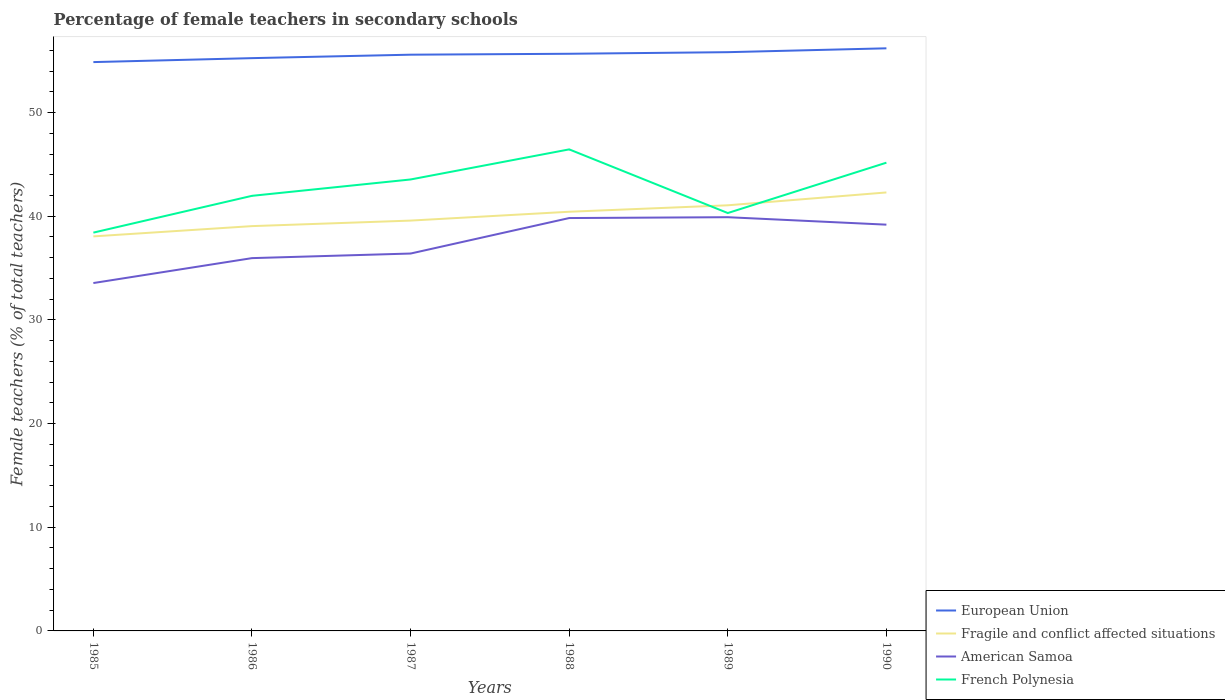How many different coloured lines are there?
Provide a succinct answer. 4. Does the line corresponding to French Polynesia intersect with the line corresponding to European Union?
Your response must be concise. No. Across all years, what is the maximum percentage of female teachers in American Samoa?
Offer a terse response. 33.56. In which year was the percentage of female teachers in French Polynesia maximum?
Make the answer very short. 1985. What is the total percentage of female teachers in American Samoa in the graph?
Your answer should be very brief. 0.64. What is the difference between the highest and the second highest percentage of female teachers in French Polynesia?
Your answer should be very brief. 8.03. What is the difference between the highest and the lowest percentage of female teachers in European Union?
Your response must be concise. 4. Is the percentage of female teachers in American Samoa strictly greater than the percentage of female teachers in Fragile and conflict affected situations over the years?
Your response must be concise. Yes. How many lines are there?
Offer a very short reply. 4. What is the difference between two consecutive major ticks on the Y-axis?
Make the answer very short. 10. Are the values on the major ticks of Y-axis written in scientific E-notation?
Make the answer very short. No. Does the graph contain any zero values?
Keep it short and to the point. No. Does the graph contain grids?
Offer a terse response. No. How are the legend labels stacked?
Keep it short and to the point. Vertical. What is the title of the graph?
Make the answer very short. Percentage of female teachers in secondary schools. What is the label or title of the X-axis?
Your answer should be compact. Years. What is the label or title of the Y-axis?
Your answer should be compact. Female teachers (% of total teachers). What is the Female teachers (% of total teachers) in European Union in 1985?
Your answer should be compact. 54.87. What is the Female teachers (% of total teachers) of Fragile and conflict affected situations in 1985?
Offer a very short reply. 38.06. What is the Female teachers (% of total teachers) of American Samoa in 1985?
Make the answer very short. 33.56. What is the Female teachers (% of total teachers) of French Polynesia in 1985?
Keep it short and to the point. 38.42. What is the Female teachers (% of total teachers) in European Union in 1986?
Provide a short and direct response. 55.25. What is the Female teachers (% of total teachers) of Fragile and conflict affected situations in 1986?
Your answer should be very brief. 39.05. What is the Female teachers (% of total teachers) in American Samoa in 1986?
Your response must be concise. 35.96. What is the Female teachers (% of total teachers) in French Polynesia in 1986?
Your answer should be very brief. 41.97. What is the Female teachers (% of total teachers) in European Union in 1987?
Provide a succinct answer. 55.58. What is the Female teachers (% of total teachers) in Fragile and conflict affected situations in 1987?
Keep it short and to the point. 39.58. What is the Female teachers (% of total teachers) of American Samoa in 1987?
Provide a succinct answer. 36.4. What is the Female teachers (% of total teachers) in French Polynesia in 1987?
Your answer should be very brief. 43.55. What is the Female teachers (% of total teachers) in European Union in 1988?
Your answer should be compact. 55.67. What is the Female teachers (% of total teachers) of Fragile and conflict affected situations in 1988?
Keep it short and to the point. 40.43. What is the Female teachers (% of total teachers) of American Samoa in 1988?
Your response must be concise. 39.83. What is the Female teachers (% of total teachers) in French Polynesia in 1988?
Keep it short and to the point. 46.45. What is the Female teachers (% of total teachers) of European Union in 1989?
Provide a short and direct response. 55.83. What is the Female teachers (% of total teachers) of Fragile and conflict affected situations in 1989?
Your answer should be very brief. 41.06. What is the Female teachers (% of total teachers) in American Samoa in 1989?
Ensure brevity in your answer.  39.91. What is the Female teachers (% of total teachers) in French Polynesia in 1989?
Keep it short and to the point. 40.31. What is the Female teachers (% of total teachers) in European Union in 1990?
Offer a terse response. 56.2. What is the Female teachers (% of total teachers) in Fragile and conflict affected situations in 1990?
Your answer should be very brief. 42.3. What is the Female teachers (% of total teachers) in American Samoa in 1990?
Provide a short and direct response. 39.19. What is the Female teachers (% of total teachers) of French Polynesia in 1990?
Offer a terse response. 45.17. Across all years, what is the maximum Female teachers (% of total teachers) of European Union?
Your answer should be compact. 56.2. Across all years, what is the maximum Female teachers (% of total teachers) of Fragile and conflict affected situations?
Ensure brevity in your answer.  42.3. Across all years, what is the maximum Female teachers (% of total teachers) of American Samoa?
Your answer should be compact. 39.91. Across all years, what is the maximum Female teachers (% of total teachers) of French Polynesia?
Offer a very short reply. 46.45. Across all years, what is the minimum Female teachers (% of total teachers) of European Union?
Offer a terse response. 54.87. Across all years, what is the minimum Female teachers (% of total teachers) in Fragile and conflict affected situations?
Provide a short and direct response. 38.06. Across all years, what is the minimum Female teachers (% of total teachers) of American Samoa?
Ensure brevity in your answer.  33.56. Across all years, what is the minimum Female teachers (% of total teachers) of French Polynesia?
Offer a terse response. 38.42. What is the total Female teachers (% of total teachers) in European Union in the graph?
Make the answer very short. 333.41. What is the total Female teachers (% of total teachers) in Fragile and conflict affected situations in the graph?
Ensure brevity in your answer.  240.48. What is the total Female teachers (% of total teachers) of American Samoa in the graph?
Provide a short and direct response. 224.85. What is the total Female teachers (% of total teachers) in French Polynesia in the graph?
Offer a very short reply. 255.87. What is the difference between the Female teachers (% of total teachers) of European Union in 1985 and that in 1986?
Ensure brevity in your answer.  -0.38. What is the difference between the Female teachers (% of total teachers) of Fragile and conflict affected situations in 1985 and that in 1986?
Give a very brief answer. -0.99. What is the difference between the Female teachers (% of total teachers) in American Samoa in 1985 and that in 1986?
Offer a terse response. -2.4. What is the difference between the Female teachers (% of total teachers) of French Polynesia in 1985 and that in 1986?
Keep it short and to the point. -3.55. What is the difference between the Female teachers (% of total teachers) of European Union in 1985 and that in 1987?
Your answer should be compact. -0.71. What is the difference between the Female teachers (% of total teachers) in Fragile and conflict affected situations in 1985 and that in 1987?
Give a very brief answer. -1.52. What is the difference between the Female teachers (% of total teachers) of American Samoa in 1985 and that in 1987?
Make the answer very short. -2.85. What is the difference between the Female teachers (% of total teachers) in French Polynesia in 1985 and that in 1987?
Make the answer very short. -5.13. What is the difference between the Female teachers (% of total teachers) of European Union in 1985 and that in 1988?
Make the answer very short. -0.8. What is the difference between the Female teachers (% of total teachers) in Fragile and conflict affected situations in 1985 and that in 1988?
Offer a very short reply. -2.38. What is the difference between the Female teachers (% of total teachers) in American Samoa in 1985 and that in 1988?
Provide a short and direct response. -6.27. What is the difference between the Female teachers (% of total teachers) in French Polynesia in 1985 and that in 1988?
Make the answer very short. -8.03. What is the difference between the Female teachers (% of total teachers) in European Union in 1985 and that in 1989?
Offer a terse response. -0.96. What is the difference between the Female teachers (% of total teachers) of Fragile and conflict affected situations in 1985 and that in 1989?
Offer a very short reply. -3. What is the difference between the Female teachers (% of total teachers) in American Samoa in 1985 and that in 1989?
Provide a short and direct response. -6.35. What is the difference between the Female teachers (% of total teachers) in French Polynesia in 1985 and that in 1989?
Make the answer very short. -1.89. What is the difference between the Female teachers (% of total teachers) of European Union in 1985 and that in 1990?
Give a very brief answer. -1.33. What is the difference between the Female teachers (% of total teachers) in Fragile and conflict affected situations in 1985 and that in 1990?
Provide a succinct answer. -4.24. What is the difference between the Female teachers (% of total teachers) in American Samoa in 1985 and that in 1990?
Offer a terse response. -5.63. What is the difference between the Female teachers (% of total teachers) of French Polynesia in 1985 and that in 1990?
Keep it short and to the point. -6.75. What is the difference between the Female teachers (% of total teachers) of European Union in 1986 and that in 1987?
Give a very brief answer. -0.33. What is the difference between the Female teachers (% of total teachers) in Fragile and conflict affected situations in 1986 and that in 1987?
Offer a terse response. -0.53. What is the difference between the Female teachers (% of total teachers) in American Samoa in 1986 and that in 1987?
Provide a succinct answer. -0.44. What is the difference between the Female teachers (% of total teachers) of French Polynesia in 1986 and that in 1987?
Give a very brief answer. -1.58. What is the difference between the Female teachers (% of total teachers) in European Union in 1986 and that in 1988?
Provide a short and direct response. -0.42. What is the difference between the Female teachers (% of total teachers) in Fragile and conflict affected situations in 1986 and that in 1988?
Ensure brevity in your answer.  -1.39. What is the difference between the Female teachers (% of total teachers) of American Samoa in 1986 and that in 1988?
Offer a very short reply. -3.87. What is the difference between the Female teachers (% of total teachers) of French Polynesia in 1986 and that in 1988?
Offer a terse response. -4.48. What is the difference between the Female teachers (% of total teachers) in European Union in 1986 and that in 1989?
Provide a short and direct response. -0.58. What is the difference between the Female teachers (% of total teachers) in Fragile and conflict affected situations in 1986 and that in 1989?
Your answer should be very brief. -2.01. What is the difference between the Female teachers (% of total teachers) of American Samoa in 1986 and that in 1989?
Your answer should be very brief. -3.95. What is the difference between the Female teachers (% of total teachers) of French Polynesia in 1986 and that in 1989?
Make the answer very short. 1.66. What is the difference between the Female teachers (% of total teachers) in European Union in 1986 and that in 1990?
Offer a terse response. -0.95. What is the difference between the Female teachers (% of total teachers) of Fragile and conflict affected situations in 1986 and that in 1990?
Offer a very short reply. -3.25. What is the difference between the Female teachers (% of total teachers) in American Samoa in 1986 and that in 1990?
Provide a succinct answer. -3.23. What is the difference between the Female teachers (% of total teachers) in French Polynesia in 1986 and that in 1990?
Give a very brief answer. -3.2. What is the difference between the Female teachers (% of total teachers) in European Union in 1987 and that in 1988?
Your answer should be compact. -0.09. What is the difference between the Female teachers (% of total teachers) of Fragile and conflict affected situations in 1987 and that in 1988?
Offer a very short reply. -0.85. What is the difference between the Female teachers (% of total teachers) of American Samoa in 1987 and that in 1988?
Offer a very short reply. -3.42. What is the difference between the Female teachers (% of total teachers) of French Polynesia in 1987 and that in 1988?
Your response must be concise. -2.9. What is the difference between the Female teachers (% of total teachers) in European Union in 1987 and that in 1989?
Your answer should be very brief. -0.24. What is the difference between the Female teachers (% of total teachers) of Fragile and conflict affected situations in 1987 and that in 1989?
Your answer should be very brief. -1.48. What is the difference between the Female teachers (% of total teachers) in American Samoa in 1987 and that in 1989?
Offer a very short reply. -3.5. What is the difference between the Female teachers (% of total teachers) in French Polynesia in 1987 and that in 1989?
Offer a very short reply. 3.24. What is the difference between the Female teachers (% of total teachers) of European Union in 1987 and that in 1990?
Offer a terse response. -0.62. What is the difference between the Female teachers (% of total teachers) of Fragile and conflict affected situations in 1987 and that in 1990?
Provide a short and direct response. -2.71. What is the difference between the Female teachers (% of total teachers) of American Samoa in 1987 and that in 1990?
Provide a short and direct response. -2.79. What is the difference between the Female teachers (% of total teachers) of French Polynesia in 1987 and that in 1990?
Keep it short and to the point. -1.62. What is the difference between the Female teachers (% of total teachers) in European Union in 1988 and that in 1989?
Your response must be concise. -0.15. What is the difference between the Female teachers (% of total teachers) in Fragile and conflict affected situations in 1988 and that in 1989?
Offer a terse response. -0.62. What is the difference between the Female teachers (% of total teachers) in American Samoa in 1988 and that in 1989?
Your answer should be very brief. -0.08. What is the difference between the Female teachers (% of total teachers) in French Polynesia in 1988 and that in 1989?
Provide a succinct answer. 6.14. What is the difference between the Female teachers (% of total teachers) of European Union in 1988 and that in 1990?
Provide a short and direct response. -0.53. What is the difference between the Female teachers (% of total teachers) of Fragile and conflict affected situations in 1988 and that in 1990?
Give a very brief answer. -1.86. What is the difference between the Female teachers (% of total teachers) in American Samoa in 1988 and that in 1990?
Provide a short and direct response. 0.64. What is the difference between the Female teachers (% of total teachers) of French Polynesia in 1988 and that in 1990?
Provide a succinct answer. 1.28. What is the difference between the Female teachers (% of total teachers) in European Union in 1989 and that in 1990?
Your answer should be very brief. -0.37. What is the difference between the Female teachers (% of total teachers) of Fragile and conflict affected situations in 1989 and that in 1990?
Offer a terse response. -1.24. What is the difference between the Female teachers (% of total teachers) of American Samoa in 1989 and that in 1990?
Your answer should be very brief. 0.72. What is the difference between the Female teachers (% of total teachers) of French Polynesia in 1989 and that in 1990?
Keep it short and to the point. -4.86. What is the difference between the Female teachers (% of total teachers) in European Union in 1985 and the Female teachers (% of total teachers) in Fragile and conflict affected situations in 1986?
Provide a short and direct response. 15.82. What is the difference between the Female teachers (% of total teachers) of European Union in 1985 and the Female teachers (% of total teachers) of American Samoa in 1986?
Provide a short and direct response. 18.91. What is the difference between the Female teachers (% of total teachers) in European Union in 1985 and the Female teachers (% of total teachers) in French Polynesia in 1986?
Offer a terse response. 12.9. What is the difference between the Female teachers (% of total teachers) of Fragile and conflict affected situations in 1985 and the Female teachers (% of total teachers) of American Samoa in 1986?
Give a very brief answer. 2.1. What is the difference between the Female teachers (% of total teachers) of Fragile and conflict affected situations in 1985 and the Female teachers (% of total teachers) of French Polynesia in 1986?
Offer a terse response. -3.91. What is the difference between the Female teachers (% of total teachers) of American Samoa in 1985 and the Female teachers (% of total teachers) of French Polynesia in 1986?
Offer a terse response. -8.41. What is the difference between the Female teachers (% of total teachers) in European Union in 1985 and the Female teachers (% of total teachers) in Fragile and conflict affected situations in 1987?
Offer a terse response. 15.29. What is the difference between the Female teachers (% of total teachers) in European Union in 1985 and the Female teachers (% of total teachers) in American Samoa in 1987?
Your answer should be very brief. 18.47. What is the difference between the Female teachers (% of total teachers) in European Union in 1985 and the Female teachers (% of total teachers) in French Polynesia in 1987?
Provide a short and direct response. 11.32. What is the difference between the Female teachers (% of total teachers) in Fragile and conflict affected situations in 1985 and the Female teachers (% of total teachers) in American Samoa in 1987?
Ensure brevity in your answer.  1.65. What is the difference between the Female teachers (% of total teachers) in Fragile and conflict affected situations in 1985 and the Female teachers (% of total teachers) in French Polynesia in 1987?
Ensure brevity in your answer.  -5.49. What is the difference between the Female teachers (% of total teachers) of American Samoa in 1985 and the Female teachers (% of total teachers) of French Polynesia in 1987?
Provide a succinct answer. -9.99. What is the difference between the Female teachers (% of total teachers) of European Union in 1985 and the Female teachers (% of total teachers) of Fragile and conflict affected situations in 1988?
Give a very brief answer. 14.44. What is the difference between the Female teachers (% of total teachers) in European Union in 1985 and the Female teachers (% of total teachers) in American Samoa in 1988?
Keep it short and to the point. 15.04. What is the difference between the Female teachers (% of total teachers) of European Union in 1985 and the Female teachers (% of total teachers) of French Polynesia in 1988?
Your answer should be compact. 8.42. What is the difference between the Female teachers (% of total teachers) of Fragile and conflict affected situations in 1985 and the Female teachers (% of total teachers) of American Samoa in 1988?
Offer a very short reply. -1.77. What is the difference between the Female teachers (% of total teachers) of Fragile and conflict affected situations in 1985 and the Female teachers (% of total teachers) of French Polynesia in 1988?
Offer a very short reply. -8.39. What is the difference between the Female teachers (% of total teachers) in American Samoa in 1985 and the Female teachers (% of total teachers) in French Polynesia in 1988?
Offer a very short reply. -12.89. What is the difference between the Female teachers (% of total teachers) in European Union in 1985 and the Female teachers (% of total teachers) in Fragile and conflict affected situations in 1989?
Offer a terse response. 13.81. What is the difference between the Female teachers (% of total teachers) in European Union in 1985 and the Female teachers (% of total teachers) in American Samoa in 1989?
Your answer should be very brief. 14.96. What is the difference between the Female teachers (% of total teachers) in European Union in 1985 and the Female teachers (% of total teachers) in French Polynesia in 1989?
Offer a terse response. 14.56. What is the difference between the Female teachers (% of total teachers) in Fragile and conflict affected situations in 1985 and the Female teachers (% of total teachers) in American Samoa in 1989?
Offer a very short reply. -1.85. What is the difference between the Female teachers (% of total teachers) of Fragile and conflict affected situations in 1985 and the Female teachers (% of total teachers) of French Polynesia in 1989?
Give a very brief answer. -2.25. What is the difference between the Female teachers (% of total teachers) of American Samoa in 1985 and the Female teachers (% of total teachers) of French Polynesia in 1989?
Provide a succinct answer. -6.75. What is the difference between the Female teachers (% of total teachers) of European Union in 1985 and the Female teachers (% of total teachers) of Fragile and conflict affected situations in 1990?
Provide a succinct answer. 12.57. What is the difference between the Female teachers (% of total teachers) of European Union in 1985 and the Female teachers (% of total teachers) of American Samoa in 1990?
Ensure brevity in your answer.  15.68. What is the difference between the Female teachers (% of total teachers) in European Union in 1985 and the Female teachers (% of total teachers) in French Polynesia in 1990?
Offer a terse response. 9.7. What is the difference between the Female teachers (% of total teachers) in Fragile and conflict affected situations in 1985 and the Female teachers (% of total teachers) in American Samoa in 1990?
Your answer should be compact. -1.13. What is the difference between the Female teachers (% of total teachers) of Fragile and conflict affected situations in 1985 and the Female teachers (% of total teachers) of French Polynesia in 1990?
Provide a short and direct response. -7.11. What is the difference between the Female teachers (% of total teachers) in American Samoa in 1985 and the Female teachers (% of total teachers) in French Polynesia in 1990?
Ensure brevity in your answer.  -11.61. What is the difference between the Female teachers (% of total teachers) of European Union in 1986 and the Female teachers (% of total teachers) of Fragile and conflict affected situations in 1987?
Keep it short and to the point. 15.67. What is the difference between the Female teachers (% of total teachers) in European Union in 1986 and the Female teachers (% of total teachers) in American Samoa in 1987?
Your answer should be very brief. 18.85. What is the difference between the Female teachers (% of total teachers) of European Union in 1986 and the Female teachers (% of total teachers) of French Polynesia in 1987?
Make the answer very short. 11.7. What is the difference between the Female teachers (% of total teachers) in Fragile and conflict affected situations in 1986 and the Female teachers (% of total teachers) in American Samoa in 1987?
Provide a short and direct response. 2.65. What is the difference between the Female teachers (% of total teachers) in Fragile and conflict affected situations in 1986 and the Female teachers (% of total teachers) in French Polynesia in 1987?
Provide a short and direct response. -4.5. What is the difference between the Female teachers (% of total teachers) of American Samoa in 1986 and the Female teachers (% of total teachers) of French Polynesia in 1987?
Give a very brief answer. -7.59. What is the difference between the Female teachers (% of total teachers) of European Union in 1986 and the Female teachers (% of total teachers) of Fragile and conflict affected situations in 1988?
Your answer should be compact. 14.82. What is the difference between the Female teachers (% of total teachers) in European Union in 1986 and the Female teachers (% of total teachers) in American Samoa in 1988?
Your answer should be very brief. 15.43. What is the difference between the Female teachers (% of total teachers) of European Union in 1986 and the Female teachers (% of total teachers) of French Polynesia in 1988?
Keep it short and to the point. 8.8. What is the difference between the Female teachers (% of total teachers) of Fragile and conflict affected situations in 1986 and the Female teachers (% of total teachers) of American Samoa in 1988?
Keep it short and to the point. -0.78. What is the difference between the Female teachers (% of total teachers) of Fragile and conflict affected situations in 1986 and the Female teachers (% of total teachers) of French Polynesia in 1988?
Provide a succinct answer. -7.4. What is the difference between the Female teachers (% of total teachers) in American Samoa in 1986 and the Female teachers (% of total teachers) in French Polynesia in 1988?
Give a very brief answer. -10.49. What is the difference between the Female teachers (% of total teachers) in European Union in 1986 and the Female teachers (% of total teachers) in Fragile and conflict affected situations in 1989?
Keep it short and to the point. 14.2. What is the difference between the Female teachers (% of total teachers) in European Union in 1986 and the Female teachers (% of total teachers) in American Samoa in 1989?
Offer a very short reply. 15.34. What is the difference between the Female teachers (% of total teachers) of European Union in 1986 and the Female teachers (% of total teachers) of French Polynesia in 1989?
Your response must be concise. 14.94. What is the difference between the Female teachers (% of total teachers) of Fragile and conflict affected situations in 1986 and the Female teachers (% of total teachers) of American Samoa in 1989?
Make the answer very short. -0.86. What is the difference between the Female teachers (% of total teachers) in Fragile and conflict affected situations in 1986 and the Female teachers (% of total teachers) in French Polynesia in 1989?
Provide a succinct answer. -1.26. What is the difference between the Female teachers (% of total teachers) in American Samoa in 1986 and the Female teachers (% of total teachers) in French Polynesia in 1989?
Provide a short and direct response. -4.35. What is the difference between the Female teachers (% of total teachers) of European Union in 1986 and the Female teachers (% of total teachers) of Fragile and conflict affected situations in 1990?
Make the answer very short. 12.96. What is the difference between the Female teachers (% of total teachers) in European Union in 1986 and the Female teachers (% of total teachers) in American Samoa in 1990?
Ensure brevity in your answer.  16.06. What is the difference between the Female teachers (% of total teachers) of European Union in 1986 and the Female teachers (% of total teachers) of French Polynesia in 1990?
Offer a terse response. 10.08. What is the difference between the Female teachers (% of total teachers) in Fragile and conflict affected situations in 1986 and the Female teachers (% of total teachers) in American Samoa in 1990?
Give a very brief answer. -0.14. What is the difference between the Female teachers (% of total teachers) in Fragile and conflict affected situations in 1986 and the Female teachers (% of total teachers) in French Polynesia in 1990?
Offer a very short reply. -6.12. What is the difference between the Female teachers (% of total teachers) in American Samoa in 1986 and the Female teachers (% of total teachers) in French Polynesia in 1990?
Your answer should be very brief. -9.21. What is the difference between the Female teachers (% of total teachers) in European Union in 1987 and the Female teachers (% of total teachers) in Fragile and conflict affected situations in 1988?
Your answer should be very brief. 15.15. What is the difference between the Female teachers (% of total teachers) of European Union in 1987 and the Female teachers (% of total teachers) of American Samoa in 1988?
Make the answer very short. 15.76. What is the difference between the Female teachers (% of total teachers) of European Union in 1987 and the Female teachers (% of total teachers) of French Polynesia in 1988?
Keep it short and to the point. 9.13. What is the difference between the Female teachers (% of total teachers) in Fragile and conflict affected situations in 1987 and the Female teachers (% of total teachers) in American Samoa in 1988?
Ensure brevity in your answer.  -0.24. What is the difference between the Female teachers (% of total teachers) of Fragile and conflict affected situations in 1987 and the Female teachers (% of total teachers) of French Polynesia in 1988?
Your answer should be very brief. -6.87. What is the difference between the Female teachers (% of total teachers) in American Samoa in 1987 and the Female teachers (% of total teachers) in French Polynesia in 1988?
Offer a terse response. -10.05. What is the difference between the Female teachers (% of total teachers) of European Union in 1987 and the Female teachers (% of total teachers) of Fragile and conflict affected situations in 1989?
Offer a terse response. 14.53. What is the difference between the Female teachers (% of total teachers) of European Union in 1987 and the Female teachers (% of total teachers) of American Samoa in 1989?
Ensure brevity in your answer.  15.68. What is the difference between the Female teachers (% of total teachers) of European Union in 1987 and the Female teachers (% of total teachers) of French Polynesia in 1989?
Give a very brief answer. 15.27. What is the difference between the Female teachers (% of total teachers) in Fragile and conflict affected situations in 1987 and the Female teachers (% of total teachers) in American Samoa in 1989?
Ensure brevity in your answer.  -0.33. What is the difference between the Female teachers (% of total teachers) of Fragile and conflict affected situations in 1987 and the Female teachers (% of total teachers) of French Polynesia in 1989?
Give a very brief answer. -0.73. What is the difference between the Female teachers (% of total teachers) in American Samoa in 1987 and the Female teachers (% of total teachers) in French Polynesia in 1989?
Give a very brief answer. -3.91. What is the difference between the Female teachers (% of total teachers) in European Union in 1987 and the Female teachers (% of total teachers) in Fragile and conflict affected situations in 1990?
Your response must be concise. 13.29. What is the difference between the Female teachers (% of total teachers) of European Union in 1987 and the Female teachers (% of total teachers) of American Samoa in 1990?
Offer a very short reply. 16.4. What is the difference between the Female teachers (% of total teachers) in European Union in 1987 and the Female teachers (% of total teachers) in French Polynesia in 1990?
Provide a succinct answer. 10.42. What is the difference between the Female teachers (% of total teachers) of Fragile and conflict affected situations in 1987 and the Female teachers (% of total teachers) of American Samoa in 1990?
Ensure brevity in your answer.  0.39. What is the difference between the Female teachers (% of total teachers) of Fragile and conflict affected situations in 1987 and the Female teachers (% of total teachers) of French Polynesia in 1990?
Provide a succinct answer. -5.59. What is the difference between the Female teachers (% of total teachers) in American Samoa in 1987 and the Female teachers (% of total teachers) in French Polynesia in 1990?
Offer a terse response. -8.77. What is the difference between the Female teachers (% of total teachers) of European Union in 1988 and the Female teachers (% of total teachers) of Fragile and conflict affected situations in 1989?
Offer a terse response. 14.62. What is the difference between the Female teachers (% of total teachers) in European Union in 1988 and the Female teachers (% of total teachers) in American Samoa in 1989?
Offer a very short reply. 15.77. What is the difference between the Female teachers (% of total teachers) of European Union in 1988 and the Female teachers (% of total teachers) of French Polynesia in 1989?
Provide a short and direct response. 15.36. What is the difference between the Female teachers (% of total teachers) of Fragile and conflict affected situations in 1988 and the Female teachers (% of total teachers) of American Samoa in 1989?
Your answer should be very brief. 0.53. What is the difference between the Female teachers (% of total teachers) in Fragile and conflict affected situations in 1988 and the Female teachers (% of total teachers) in French Polynesia in 1989?
Provide a succinct answer. 0.12. What is the difference between the Female teachers (% of total teachers) in American Samoa in 1988 and the Female teachers (% of total teachers) in French Polynesia in 1989?
Give a very brief answer. -0.48. What is the difference between the Female teachers (% of total teachers) in European Union in 1988 and the Female teachers (% of total teachers) in Fragile and conflict affected situations in 1990?
Make the answer very short. 13.38. What is the difference between the Female teachers (% of total teachers) of European Union in 1988 and the Female teachers (% of total teachers) of American Samoa in 1990?
Offer a very short reply. 16.48. What is the difference between the Female teachers (% of total teachers) of European Union in 1988 and the Female teachers (% of total teachers) of French Polynesia in 1990?
Your answer should be very brief. 10.51. What is the difference between the Female teachers (% of total teachers) of Fragile and conflict affected situations in 1988 and the Female teachers (% of total teachers) of American Samoa in 1990?
Provide a succinct answer. 1.25. What is the difference between the Female teachers (% of total teachers) in Fragile and conflict affected situations in 1988 and the Female teachers (% of total teachers) in French Polynesia in 1990?
Make the answer very short. -4.73. What is the difference between the Female teachers (% of total teachers) of American Samoa in 1988 and the Female teachers (% of total teachers) of French Polynesia in 1990?
Your answer should be very brief. -5.34. What is the difference between the Female teachers (% of total teachers) of European Union in 1989 and the Female teachers (% of total teachers) of Fragile and conflict affected situations in 1990?
Ensure brevity in your answer.  13.53. What is the difference between the Female teachers (% of total teachers) of European Union in 1989 and the Female teachers (% of total teachers) of American Samoa in 1990?
Ensure brevity in your answer.  16.64. What is the difference between the Female teachers (% of total teachers) in European Union in 1989 and the Female teachers (% of total teachers) in French Polynesia in 1990?
Offer a terse response. 10.66. What is the difference between the Female teachers (% of total teachers) in Fragile and conflict affected situations in 1989 and the Female teachers (% of total teachers) in American Samoa in 1990?
Offer a very short reply. 1.87. What is the difference between the Female teachers (% of total teachers) in Fragile and conflict affected situations in 1989 and the Female teachers (% of total teachers) in French Polynesia in 1990?
Your answer should be very brief. -4.11. What is the difference between the Female teachers (% of total teachers) of American Samoa in 1989 and the Female teachers (% of total teachers) of French Polynesia in 1990?
Your answer should be compact. -5.26. What is the average Female teachers (% of total teachers) of European Union per year?
Give a very brief answer. 55.57. What is the average Female teachers (% of total teachers) of Fragile and conflict affected situations per year?
Your answer should be very brief. 40.08. What is the average Female teachers (% of total teachers) of American Samoa per year?
Your answer should be compact. 37.47. What is the average Female teachers (% of total teachers) of French Polynesia per year?
Offer a very short reply. 42.65. In the year 1985, what is the difference between the Female teachers (% of total teachers) of European Union and Female teachers (% of total teachers) of Fragile and conflict affected situations?
Offer a terse response. 16.81. In the year 1985, what is the difference between the Female teachers (% of total teachers) of European Union and Female teachers (% of total teachers) of American Samoa?
Offer a very short reply. 21.31. In the year 1985, what is the difference between the Female teachers (% of total teachers) in European Union and Female teachers (% of total teachers) in French Polynesia?
Your answer should be very brief. 16.45. In the year 1985, what is the difference between the Female teachers (% of total teachers) of Fragile and conflict affected situations and Female teachers (% of total teachers) of American Samoa?
Provide a succinct answer. 4.5. In the year 1985, what is the difference between the Female teachers (% of total teachers) of Fragile and conflict affected situations and Female teachers (% of total teachers) of French Polynesia?
Your response must be concise. -0.36. In the year 1985, what is the difference between the Female teachers (% of total teachers) in American Samoa and Female teachers (% of total teachers) in French Polynesia?
Ensure brevity in your answer.  -4.86. In the year 1986, what is the difference between the Female teachers (% of total teachers) of European Union and Female teachers (% of total teachers) of Fragile and conflict affected situations?
Offer a terse response. 16.2. In the year 1986, what is the difference between the Female teachers (% of total teachers) in European Union and Female teachers (% of total teachers) in American Samoa?
Offer a very short reply. 19.29. In the year 1986, what is the difference between the Female teachers (% of total teachers) in European Union and Female teachers (% of total teachers) in French Polynesia?
Your answer should be very brief. 13.28. In the year 1986, what is the difference between the Female teachers (% of total teachers) in Fragile and conflict affected situations and Female teachers (% of total teachers) in American Samoa?
Your answer should be very brief. 3.09. In the year 1986, what is the difference between the Female teachers (% of total teachers) of Fragile and conflict affected situations and Female teachers (% of total teachers) of French Polynesia?
Provide a short and direct response. -2.92. In the year 1986, what is the difference between the Female teachers (% of total teachers) in American Samoa and Female teachers (% of total teachers) in French Polynesia?
Your response must be concise. -6.01. In the year 1987, what is the difference between the Female teachers (% of total teachers) in European Union and Female teachers (% of total teachers) in Fragile and conflict affected situations?
Your response must be concise. 16. In the year 1987, what is the difference between the Female teachers (% of total teachers) of European Union and Female teachers (% of total teachers) of American Samoa?
Your answer should be compact. 19.18. In the year 1987, what is the difference between the Female teachers (% of total teachers) of European Union and Female teachers (% of total teachers) of French Polynesia?
Offer a very short reply. 12.04. In the year 1987, what is the difference between the Female teachers (% of total teachers) of Fragile and conflict affected situations and Female teachers (% of total teachers) of American Samoa?
Provide a short and direct response. 3.18. In the year 1987, what is the difference between the Female teachers (% of total teachers) in Fragile and conflict affected situations and Female teachers (% of total teachers) in French Polynesia?
Keep it short and to the point. -3.97. In the year 1987, what is the difference between the Female teachers (% of total teachers) in American Samoa and Female teachers (% of total teachers) in French Polynesia?
Keep it short and to the point. -7.14. In the year 1988, what is the difference between the Female teachers (% of total teachers) of European Union and Female teachers (% of total teachers) of Fragile and conflict affected situations?
Your answer should be compact. 15.24. In the year 1988, what is the difference between the Female teachers (% of total teachers) of European Union and Female teachers (% of total teachers) of American Samoa?
Offer a very short reply. 15.85. In the year 1988, what is the difference between the Female teachers (% of total teachers) in European Union and Female teachers (% of total teachers) in French Polynesia?
Your response must be concise. 9.22. In the year 1988, what is the difference between the Female teachers (% of total teachers) in Fragile and conflict affected situations and Female teachers (% of total teachers) in American Samoa?
Provide a succinct answer. 0.61. In the year 1988, what is the difference between the Female teachers (% of total teachers) of Fragile and conflict affected situations and Female teachers (% of total teachers) of French Polynesia?
Keep it short and to the point. -6.02. In the year 1988, what is the difference between the Female teachers (% of total teachers) in American Samoa and Female teachers (% of total teachers) in French Polynesia?
Keep it short and to the point. -6.62. In the year 1989, what is the difference between the Female teachers (% of total teachers) of European Union and Female teachers (% of total teachers) of Fragile and conflict affected situations?
Provide a short and direct response. 14.77. In the year 1989, what is the difference between the Female teachers (% of total teachers) in European Union and Female teachers (% of total teachers) in American Samoa?
Keep it short and to the point. 15.92. In the year 1989, what is the difference between the Female teachers (% of total teachers) in European Union and Female teachers (% of total teachers) in French Polynesia?
Provide a short and direct response. 15.52. In the year 1989, what is the difference between the Female teachers (% of total teachers) of Fragile and conflict affected situations and Female teachers (% of total teachers) of American Samoa?
Your response must be concise. 1.15. In the year 1989, what is the difference between the Female teachers (% of total teachers) in Fragile and conflict affected situations and Female teachers (% of total teachers) in French Polynesia?
Provide a succinct answer. 0.75. In the year 1989, what is the difference between the Female teachers (% of total teachers) in American Samoa and Female teachers (% of total teachers) in French Polynesia?
Offer a very short reply. -0.4. In the year 1990, what is the difference between the Female teachers (% of total teachers) in European Union and Female teachers (% of total teachers) in Fragile and conflict affected situations?
Provide a short and direct response. 13.9. In the year 1990, what is the difference between the Female teachers (% of total teachers) of European Union and Female teachers (% of total teachers) of American Samoa?
Your answer should be very brief. 17.01. In the year 1990, what is the difference between the Female teachers (% of total teachers) in European Union and Female teachers (% of total teachers) in French Polynesia?
Make the answer very short. 11.03. In the year 1990, what is the difference between the Female teachers (% of total teachers) in Fragile and conflict affected situations and Female teachers (% of total teachers) in American Samoa?
Your answer should be very brief. 3.11. In the year 1990, what is the difference between the Female teachers (% of total teachers) in Fragile and conflict affected situations and Female teachers (% of total teachers) in French Polynesia?
Offer a terse response. -2.87. In the year 1990, what is the difference between the Female teachers (% of total teachers) in American Samoa and Female teachers (% of total teachers) in French Polynesia?
Give a very brief answer. -5.98. What is the ratio of the Female teachers (% of total teachers) of European Union in 1985 to that in 1986?
Make the answer very short. 0.99. What is the ratio of the Female teachers (% of total teachers) of Fragile and conflict affected situations in 1985 to that in 1986?
Provide a short and direct response. 0.97. What is the ratio of the Female teachers (% of total teachers) of American Samoa in 1985 to that in 1986?
Your response must be concise. 0.93. What is the ratio of the Female teachers (% of total teachers) of French Polynesia in 1985 to that in 1986?
Your answer should be compact. 0.92. What is the ratio of the Female teachers (% of total teachers) of European Union in 1985 to that in 1987?
Offer a very short reply. 0.99. What is the ratio of the Female teachers (% of total teachers) of Fragile and conflict affected situations in 1985 to that in 1987?
Give a very brief answer. 0.96. What is the ratio of the Female teachers (% of total teachers) in American Samoa in 1985 to that in 1987?
Offer a terse response. 0.92. What is the ratio of the Female teachers (% of total teachers) in French Polynesia in 1985 to that in 1987?
Your response must be concise. 0.88. What is the ratio of the Female teachers (% of total teachers) of European Union in 1985 to that in 1988?
Offer a very short reply. 0.99. What is the ratio of the Female teachers (% of total teachers) of Fragile and conflict affected situations in 1985 to that in 1988?
Offer a terse response. 0.94. What is the ratio of the Female teachers (% of total teachers) of American Samoa in 1985 to that in 1988?
Offer a terse response. 0.84. What is the ratio of the Female teachers (% of total teachers) in French Polynesia in 1985 to that in 1988?
Give a very brief answer. 0.83. What is the ratio of the Female teachers (% of total teachers) in European Union in 1985 to that in 1989?
Keep it short and to the point. 0.98. What is the ratio of the Female teachers (% of total teachers) in Fragile and conflict affected situations in 1985 to that in 1989?
Provide a succinct answer. 0.93. What is the ratio of the Female teachers (% of total teachers) in American Samoa in 1985 to that in 1989?
Keep it short and to the point. 0.84. What is the ratio of the Female teachers (% of total teachers) in French Polynesia in 1985 to that in 1989?
Offer a very short reply. 0.95. What is the ratio of the Female teachers (% of total teachers) in European Union in 1985 to that in 1990?
Ensure brevity in your answer.  0.98. What is the ratio of the Female teachers (% of total teachers) in Fragile and conflict affected situations in 1985 to that in 1990?
Provide a succinct answer. 0.9. What is the ratio of the Female teachers (% of total teachers) in American Samoa in 1985 to that in 1990?
Make the answer very short. 0.86. What is the ratio of the Female teachers (% of total teachers) of French Polynesia in 1985 to that in 1990?
Ensure brevity in your answer.  0.85. What is the ratio of the Female teachers (% of total teachers) in European Union in 1986 to that in 1987?
Make the answer very short. 0.99. What is the ratio of the Female teachers (% of total teachers) in Fragile and conflict affected situations in 1986 to that in 1987?
Keep it short and to the point. 0.99. What is the ratio of the Female teachers (% of total teachers) in American Samoa in 1986 to that in 1987?
Give a very brief answer. 0.99. What is the ratio of the Female teachers (% of total teachers) in French Polynesia in 1986 to that in 1987?
Your response must be concise. 0.96. What is the ratio of the Female teachers (% of total teachers) of European Union in 1986 to that in 1988?
Keep it short and to the point. 0.99. What is the ratio of the Female teachers (% of total teachers) in Fragile and conflict affected situations in 1986 to that in 1988?
Offer a very short reply. 0.97. What is the ratio of the Female teachers (% of total teachers) of American Samoa in 1986 to that in 1988?
Offer a terse response. 0.9. What is the ratio of the Female teachers (% of total teachers) of French Polynesia in 1986 to that in 1988?
Your answer should be very brief. 0.9. What is the ratio of the Female teachers (% of total teachers) in European Union in 1986 to that in 1989?
Provide a short and direct response. 0.99. What is the ratio of the Female teachers (% of total teachers) in Fragile and conflict affected situations in 1986 to that in 1989?
Keep it short and to the point. 0.95. What is the ratio of the Female teachers (% of total teachers) in American Samoa in 1986 to that in 1989?
Your answer should be compact. 0.9. What is the ratio of the Female teachers (% of total teachers) of French Polynesia in 1986 to that in 1989?
Your response must be concise. 1.04. What is the ratio of the Female teachers (% of total teachers) of European Union in 1986 to that in 1990?
Your response must be concise. 0.98. What is the ratio of the Female teachers (% of total teachers) in Fragile and conflict affected situations in 1986 to that in 1990?
Keep it short and to the point. 0.92. What is the ratio of the Female teachers (% of total teachers) of American Samoa in 1986 to that in 1990?
Give a very brief answer. 0.92. What is the ratio of the Female teachers (% of total teachers) of French Polynesia in 1986 to that in 1990?
Offer a very short reply. 0.93. What is the ratio of the Female teachers (% of total teachers) of Fragile and conflict affected situations in 1987 to that in 1988?
Provide a succinct answer. 0.98. What is the ratio of the Female teachers (% of total teachers) of American Samoa in 1987 to that in 1988?
Keep it short and to the point. 0.91. What is the ratio of the Female teachers (% of total teachers) in French Polynesia in 1987 to that in 1988?
Provide a short and direct response. 0.94. What is the ratio of the Female teachers (% of total teachers) in European Union in 1987 to that in 1989?
Your answer should be compact. 1. What is the ratio of the Female teachers (% of total teachers) of Fragile and conflict affected situations in 1987 to that in 1989?
Keep it short and to the point. 0.96. What is the ratio of the Female teachers (% of total teachers) in American Samoa in 1987 to that in 1989?
Your answer should be very brief. 0.91. What is the ratio of the Female teachers (% of total teachers) in French Polynesia in 1987 to that in 1989?
Offer a terse response. 1.08. What is the ratio of the Female teachers (% of total teachers) in European Union in 1987 to that in 1990?
Your answer should be compact. 0.99. What is the ratio of the Female teachers (% of total teachers) in Fragile and conflict affected situations in 1987 to that in 1990?
Offer a very short reply. 0.94. What is the ratio of the Female teachers (% of total teachers) of American Samoa in 1987 to that in 1990?
Provide a short and direct response. 0.93. What is the ratio of the Female teachers (% of total teachers) in French Polynesia in 1987 to that in 1990?
Provide a short and direct response. 0.96. What is the ratio of the Female teachers (% of total teachers) of European Union in 1988 to that in 1989?
Provide a short and direct response. 1. What is the ratio of the Female teachers (% of total teachers) of American Samoa in 1988 to that in 1989?
Offer a very short reply. 1. What is the ratio of the Female teachers (% of total teachers) of French Polynesia in 1988 to that in 1989?
Ensure brevity in your answer.  1.15. What is the ratio of the Female teachers (% of total teachers) in European Union in 1988 to that in 1990?
Your answer should be compact. 0.99. What is the ratio of the Female teachers (% of total teachers) in Fragile and conflict affected situations in 1988 to that in 1990?
Provide a succinct answer. 0.96. What is the ratio of the Female teachers (% of total teachers) of American Samoa in 1988 to that in 1990?
Keep it short and to the point. 1.02. What is the ratio of the Female teachers (% of total teachers) in French Polynesia in 1988 to that in 1990?
Provide a succinct answer. 1.03. What is the ratio of the Female teachers (% of total teachers) of European Union in 1989 to that in 1990?
Your answer should be very brief. 0.99. What is the ratio of the Female teachers (% of total teachers) of Fragile and conflict affected situations in 1989 to that in 1990?
Ensure brevity in your answer.  0.97. What is the ratio of the Female teachers (% of total teachers) of American Samoa in 1989 to that in 1990?
Offer a terse response. 1.02. What is the ratio of the Female teachers (% of total teachers) of French Polynesia in 1989 to that in 1990?
Offer a terse response. 0.89. What is the difference between the highest and the second highest Female teachers (% of total teachers) of European Union?
Give a very brief answer. 0.37. What is the difference between the highest and the second highest Female teachers (% of total teachers) of Fragile and conflict affected situations?
Keep it short and to the point. 1.24. What is the difference between the highest and the second highest Female teachers (% of total teachers) of American Samoa?
Your answer should be compact. 0.08. What is the difference between the highest and the second highest Female teachers (% of total teachers) of French Polynesia?
Your response must be concise. 1.28. What is the difference between the highest and the lowest Female teachers (% of total teachers) of European Union?
Give a very brief answer. 1.33. What is the difference between the highest and the lowest Female teachers (% of total teachers) in Fragile and conflict affected situations?
Provide a succinct answer. 4.24. What is the difference between the highest and the lowest Female teachers (% of total teachers) in American Samoa?
Provide a short and direct response. 6.35. What is the difference between the highest and the lowest Female teachers (% of total teachers) in French Polynesia?
Make the answer very short. 8.03. 